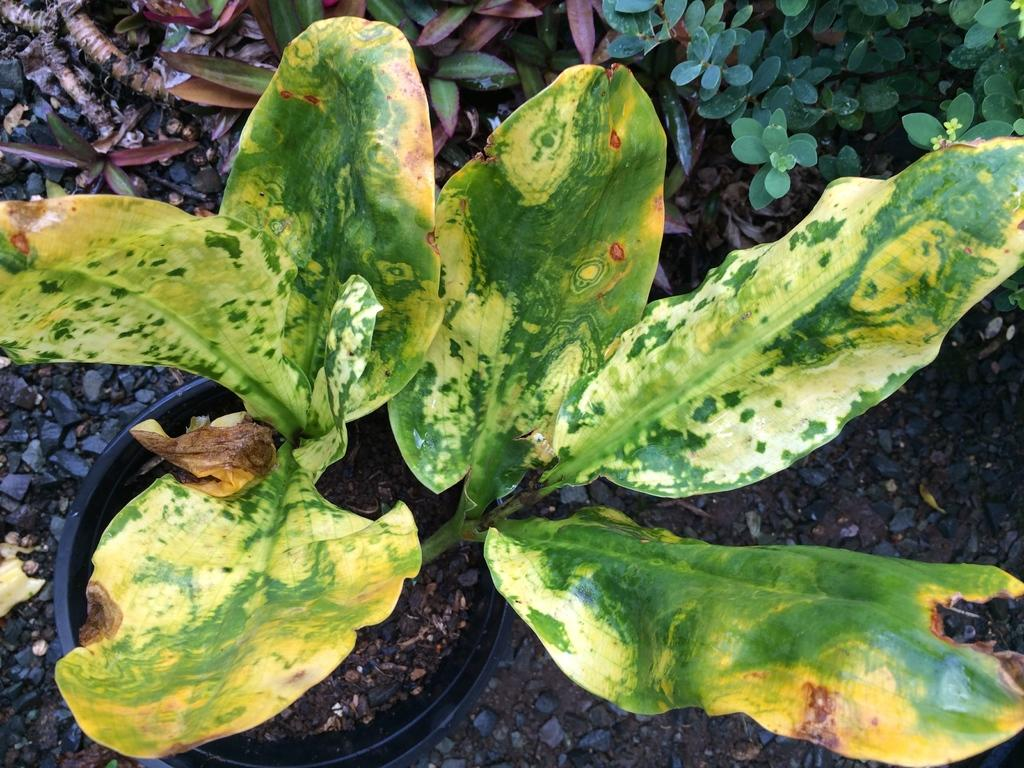What type of living organisms can be seen in the image? Plants can be seen in the image. What type of fork is used to request a word from the plants in the image? There is no fork or request for a word present in the image, as it only features plants. 